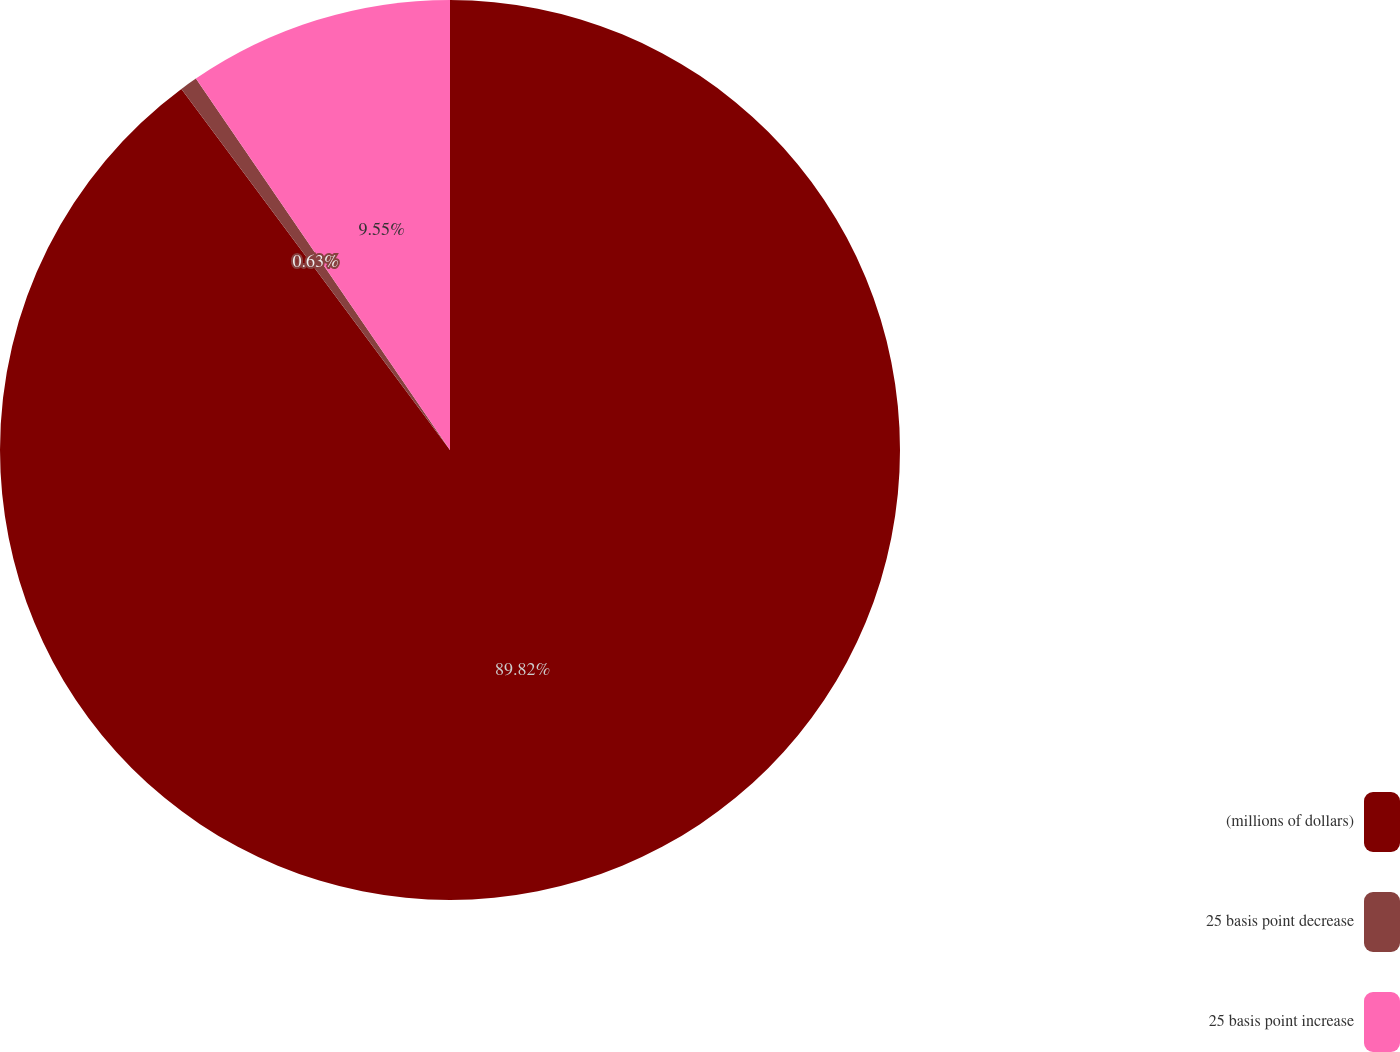Convert chart to OTSL. <chart><loc_0><loc_0><loc_500><loc_500><pie_chart><fcel>(millions of dollars)<fcel>25 basis point decrease<fcel>25 basis point increase<nl><fcel>89.82%<fcel>0.63%<fcel>9.55%<nl></chart> 